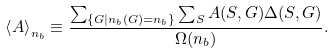Convert formula to latex. <formula><loc_0><loc_0><loc_500><loc_500>\left < A \right > _ { n _ { b } } \equiv \frac { \sum _ { \{ G | n _ { b } ( G ) = n _ { b } \} } \sum _ { S } A ( S , G ) \Delta ( S , G ) } { \Omega ( n _ { b } ) } .</formula> 